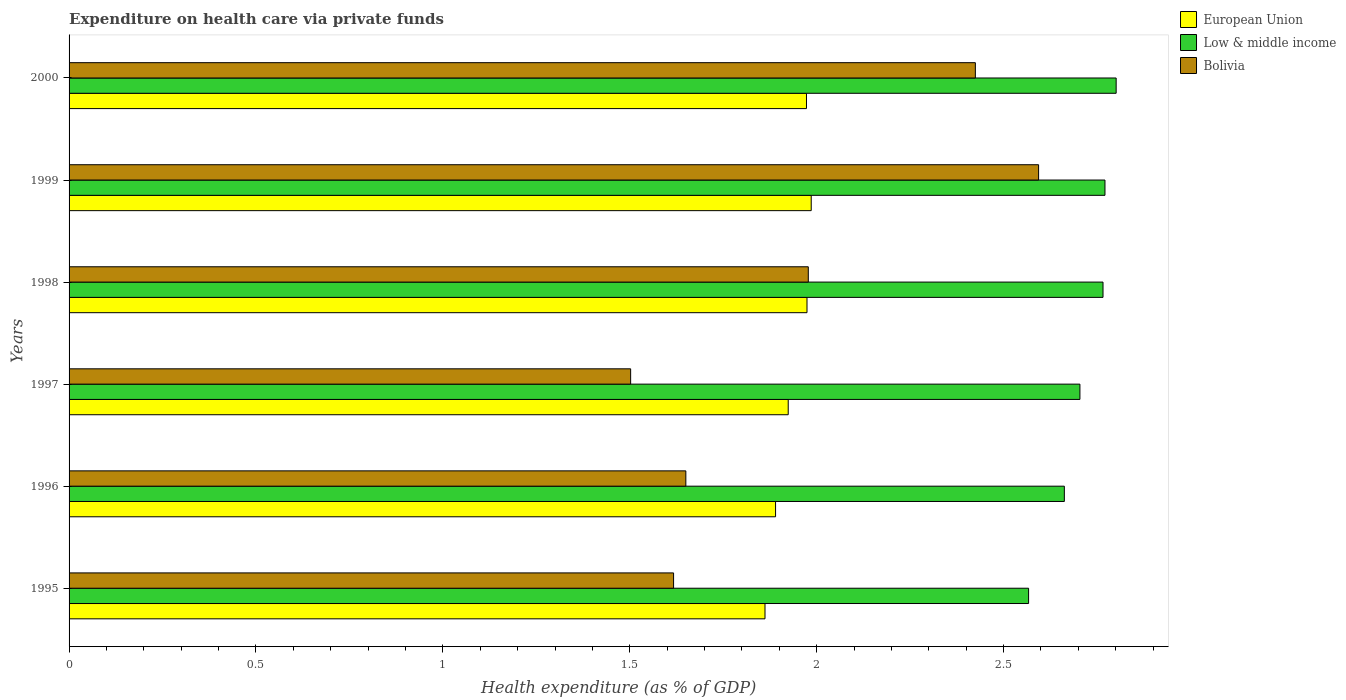How many different coloured bars are there?
Make the answer very short. 3. What is the expenditure made on health care in Low & middle income in 1995?
Your response must be concise. 2.57. Across all years, what is the maximum expenditure made on health care in Low & middle income?
Ensure brevity in your answer.  2.8. Across all years, what is the minimum expenditure made on health care in Low & middle income?
Ensure brevity in your answer.  2.57. In which year was the expenditure made on health care in Low & middle income maximum?
Keep it short and to the point. 2000. What is the total expenditure made on health care in Low & middle income in the graph?
Offer a very short reply. 16.27. What is the difference between the expenditure made on health care in European Union in 1995 and that in 1997?
Your answer should be compact. -0.06. What is the difference between the expenditure made on health care in Low & middle income in 1997 and the expenditure made on health care in European Union in 1995?
Your response must be concise. 0.84. What is the average expenditure made on health care in European Union per year?
Your answer should be very brief. 1.93. In the year 1999, what is the difference between the expenditure made on health care in Low & middle income and expenditure made on health care in European Union?
Your answer should be compact. 0.79. In how many years, is the expenditure made on health care in Low & middle income greater than 1.1 %?
Your answer should be compact. 6. What is the ratio of the expenditure made on health care in European Union in 1999 to that in 2000?
Offer a very short reply. 1.01. Is the expenditure made on health care in Bolivia in 1995 less than that in 1999?
Ensure brevity in your answer.  Yes. Is the difference between the expenditure made on health care in Low & middle income in 1995 and 1999 greater than the difference between the expenditure made on health care in European Union in 1995 and 1999?
Your answer should be very brief. No. What is the difference between the highest and the second highest expenditure made on health care in Bolivia?
Make the answer very short. 0.17. What is the difference between the highest and the lowest expenditure made on health care in Low & middle income?
Provide a short and direct response. 0.23. What does the 3rd bar from the top in 1997 represents?
Ensure brevity in your answer.  European Union. How many years are there in the graph?
Your response must be concise. 6. Are the values on the major ticks of X-axis written in scientific E-notation?
Offer a very short reply. No. What is the title of the graph?
Ensure brevity in your answer.  Expenditure on health care via private funds. Does "Australia" appear as one of the legend labels in the graph?
Ensure brevity in your answer.  No. What is the label or title of the X-axis?
Give a very brief answer. Health expenditure (as % of GDP). What is the label or title of the Y-axis?
Keep it short and to the point. Years. What is the Health expenditure (as % of GDP) in European Union in 1995?
Make the answer very short. 1.86. What is the Health expenditure (as % of GDP) of Low & middle income in 1995?
Your response must be concise. 2.57. What is the Health expenditure (as % of GDP) in Bolivia in 1995?
Ensure brevity in your answer.  1.62. What is the Health expenditure (as % of GDP) in European Union in 1996?
Provide a short and direct response. 1.89. What is the Health expenditure (as % of GDP) of Low & middle income in 1996?
Provide a short and direct response. 2.66. What is the Health expenditure (as % of GDP) of Bolivia in 1996?
Offer a very short reply. 1.65. What is the Health expenditure (as % of GDP) of European Union in 1997?
Offer a terse response. 1.92. What is the Health expenditure (as % of GDP) in Low & middle income in 1997?
Your response must be concise. 2.7. What is the Health expenditure (as % of GDP) in Bolivia in 1997?
Keep it short and to the point. 1.5. What is the Health expenditure (as % of GDP) in European Union in 1998?
Provide a succinct answer. 1.97. What is the Health expenditure (as % of GDP) of Low & middle income in 1998?
Offer a very short reply. 2.77. What is the Health expenditure (as % of GDP) in Bolivia in 1998?
Provide a succinct answer. 1.98. What is the Health expenditure (as % of GDP) in European Union in 1999?
Keep it short and to the point. 1.99. What is the Health expenditure (as % of GDP) of Low & middle income in 1999?
Give a very brief answer. 2.77. What is the Health expenditure (as % of GDP) in Bolivia in 1999?
Your answer should be compact. 2.59. What is the Health expenditure (as % of GDP) in European Union in 2000?
Keep it short and to the point. 1.97. What is the Health expenditure (as % of GDP) in Low & middle income in 2000?
Give a very brief answer. 2.8. What is the Health expenditure (as % of GDP) of Bolivia in 2000?
Keep it short and to the point. 2.42. Across all years, what is the maximum Health expenditure (as % of GDP) of European Union?
Keep it short and to the point. 1.99. Across all years, what is the maximum Health expenditure (as % of GDP) in Low & middle income?
Make the answer very short. 2.8. Across all years, what is the maximum Health expenditure (as % of GDP) of Bolivia?
Give a very brief answer. 2.59. Across all years, what is the minimum Health expenditure (as % of GDP) of European Union?
Make the answer very short. 1.86. Across all years, what is the minimum Health expenditure (as % of GDP) in Low & middle income?
Give a very brief answer. 2.57. Across all years, what is the minimum Health expenditure (as % of GDP) of Bolivia?
Your response must be concise. 1.5. What is the total Health expenditure (as % of GDP) of European Union in the graph?
Provide a short and direct response. 11.61. What is the total Health expenditure (as % of GDP) of Low & middle income in the graph?
Keep it short and to the point. 16.27. What is the total Health expenditure (as % of GDP) of Bolivia in the graph?
Offer a very short reply. 11.77. What is the difference between the Health expenditure (as % of GDP) in European Union in 1995 and that in 1996?
Provide a short and direct response. -0.03. What is the difference between the Health expenditure (as % of GDP) in Low & middle income in 1995 and that in 1996?
Offer a very short reply. -0.1. What is the difference between the Health expenditure (as % of GDP) in Bolivia in 1995 and that in 1996?
Ensure brevity in your answer.  -0.03. What is the difference between the Health expenditure (as % of GDP) in European Union in 1995 and that in 1997?
Ensure brevity in your answer.  -0.06. What is the difference between the Health expenditure (as % of GDP) in Low & middle income in 1995 and that in 1997?
Your answer should be compact. -0.14. What is the difference between the Health expenditure (as % of GDP) in Bolivia in 1995 and that in 1997?
Offer a terse response. 0.11. What is the difference between the Health expenditure (as % of GDP) in European Union in 1995 and that in 1998?
Your answer should be very brief. -0.11. What is the difference between the Health expenditure (as % of GDP) in Low & middle income in 1995 and that in 1998?
Make the answer very short. -0.2. What is the difference between the Health expenditure (as % of GDP) of Bolivia in 1995 and that in 1998?
Your answer should be compact. -0.36. What is the difference between the Health expenditure (as % of GDP) of European Union in 1995 and that in 1999?
Your response must be concise. -0.12. What is the difference between the Health expenditure (as % of GDP) of Low & middle income in 1995 and that in 1999?
Keep it short and to the point. -0.2. What is the difference between the Health expenditure (as % of GDP) in Bolivia in 1995 and that in 1999?
Keep it short and to the point. -0.98. What is the difference between the Health expenditure (as % of GDP) of European Union in 1995 and that in 2000?
Provide a short and direct response. -0.11. What is the difference between the Health expenditure (as % of GDP) in Low & middle income in 1995 and that in 2000?
Give a very brief answer. -0.23. What is the difference between the Health expenditure (as % of GDP) in Bolivia in 1995 and that in 2000?
Your answer should be compact. -0.81. What is the difference between the Health expenditure (as % of GDP) in European Union in 1996 and that in 1997?
Provide a succinct answer. -0.03. What is the difference between the Health expenditure (as % of GDP) of Low & middle income in 1996 and that in 1997?
Provide a succinct answer. -0.04. What is the difference between the Health expenditure (as % of GDP) in Bolivia in 1996 and that in 1997?
Keep it short and to the point. 0.15. What is the difference between the Health expenditure (as % of GDP) of European Union in 1996 and that in 1998?
Provide a succinct answer. -0.08. What is the difference between the Health expenditure (as % of GDP) of Low & middle income in 1996 and that in 1998?
Keep it short and to the point. -0.1. What is the difference between the Health expenditure (as % of GDP) of Bolivia in 1996 and that in 1998?
Offer a terse response. -0.33. What is the difference between the Health expenditure (as % of GDP) of European Union in 1996 and that in 1999?
Your answer should be compact. -0.1. What is the difference between the Health expenditure (as % of GDP) in Low & middle income in 1996 and that in 1999?
Offer a very short reply. -0.11. What is the difference between the Health expenditure (as % of GDP) of Bolivia in 1996 and that in 1999?
Keep it short and to the point. -0.94. What is the difference between the Health expenditure (as % of GDP) in European Union in 1996 and that in 2000?
Make the answer very short. -0.08. What is the difference between the Health expenditure (as % of GDP) of Low & middle income in 1996 and that in 2000?
Your response must be concise. -0.14. What is the difference between the Health expenditure (as % of GDP) in Bolivia in 1996 and that in 2000?
Offer a terse response. -0.77. What is the difference between the Health expenditure (as % of GDP) of European Union in 1997 and that in 1998?
Offer a terse response. -0.05. What is the difference between the Health expenditure (as % of GDP) in Low & middle income in 1997 and that in 1998?
Provide a short and direct response. -0.06. What is the difference between the Health expenditure (as % of GDP) of Bolivia in 1997 and that in 1998?
Offer a terse response. -0.48. What is the difference between the Health expenditure (as % of GDP) of European Union in 1997 and that in 1999?
Your response must be concise. -0.06. What is the difference between the Health expenditure (as % of GDP) in Low & middle income in 1997 and that in 1999?
Provide a short and direct response. -0.07. What is the difference between the Health expenditure (as % of GDP) in Bolivia in 1997 and that in 1999?
Keep it short and to the point. -1.09. What is the difference between the Health expenditure (as % of GDP) of European Union in 1997 and that in 2000?
Ensure brevity in your answer.  -0.05. What is the difference between the Health expenditure (as % of GDP) in Low & middle income in 1997 and that in 2000?
Keep it short and to the point. -0.1. What is the difference between the Health expenditure (as % of GDP) of Bolivia in 1997 and that in 2000?
Your answer should be very brief. -0.92. What is the difference between the Health expenditure (as % of GDP) in European Union in 1998 and that in 1999?
Make the answer very short. -0.01. What is the difference between the Health expenditure (as % of GDP) of Low & middle income in 1998 and that in 1999?
Provide a short and direct response. -0.01. What is the difference between the Health expenditure (as % of GDP) of Bolivia in 1998 and that in 1999?
Provide a succinct answer. -0.62. What is the difference between the Health expenditure (as % of GDP) in European Union in 1998 and that in 2000?
Give a very brief answer. 0. What is the difference between the Health expenditure (as % of GDP) in Low & middle income in 1998 and that in 2000?
Ensure brevity in your answer.  -0.04. What is the difference between the Health expenditure (as % of GDP) in Bolivia in 1998 and that in 2000?
Keep it short and to the point. -0.45. What is the difference between the Health expenditure (as % of GDP) of European Union in 1999 and that in 2000?
Offer a terse response. 0.01. What is the difference between the Health expenditure (as % of GDP) of Low & middle income in 1999 and that in 2000?
Offer a terse response. -0.03. What is the difference between the Health expenditure (as % of GDP) of Bolivia in 1999 and that in 2000?
Your answer should be very brief. 0.17. What is the difference between the Health expenditure (as % of GDP) of European Union in 1995 and the Health expenditure (as % of GDP) of Low & middle income in 1996?
Your response must be concise. -0.8. What is the difference between the Health expenditure (as % of GDP) in European Union in 1995 and the Health expenditure (as % of GDP) in Bolivia in 1996?
Your answer should be very brief. 0.21. What is the difference between the Health expenditure (as % of GDP) of Low & middle income in 1995 and the Health expenditure (as % of GDP) of Bolivia in 1996?
Provide a succinct answer. 0.92. What is the difference between the Health expenditure (as % of GDP) in European Union in 1995 and the Health expenditure (as % of GDP) in Low & middle income in 1997?
Offer a terse response. -0.84. What is the difference between the Health expenditure (as % of GDP) of European Union in 1995 and the Health expenditure (as % of GDP) of Bolivia in 1997?
Offer a terse response. 0.36. What is the difference between the Health expenditure (as % of GDP) in Low & middle income in 1995 and the Health expenditure (as % of GDP) in Bolivia in 1997?
Your response must be concise. 1.06. What is the difference between the Health expenditure (as % of GDP) of European Union in 1995 and the Health expenditure (as % of GDP) of Low & middle income in 1998?
Offer a very short reply. -0.9. What is the difference between the Health expenditure (as % of GDP) of European Union in 1995 and the Health expenditure (as % of GDP) of Bolivia in 1998?
Your response must be concise. -0.12. What is the difference between the Health expenditure (as % of GDP) of Low & middle income in 1995 and the Health expenditure (as % of GDP) of Bolivia in 1998?
Offer a very short reply. 0.59. What is the difference between the Health expenditure (as % of GDP) in European Union in 1995 and the Health expenditure (as % of GDP) in Low & middle income in 1999?
Offer a terse response. -0.91. What is the difference between the Health expenditure (as % of GDP) of European Union in 1995 and the Health expenditure (as % of GDP) of Bolivia in 1999?
Make the answer very short. -0.73. What is the difference between the Health expenditure (as % of GDP) of Low & middle income in 1995 and the Health expenditure (as % of GDP) of Bolivia in 1999?
Your answer should be very brief. -0.03. What is the difference between the Health expenditure (as % of GDP) in European Union in 1995 and the Health expenditure (as % of GDP) in Low & middle income in 2000?
Provide a succinct answer. -0.94. What is the difference between the Health expenditure (as % of GDP) of European Union in 1995 and the Health expenditure (as % of GDP) of Bolivia in 2000?
Offer a very short reply. -0.56. What is the difference between the Health expenditure (as % of GDP) in Low & middle income in 1995 and the Health expenditure (as % of GDP) in Bolivia in 2000?
Give a very brief answer. 0.14. What is the difference between the Health expenditure (as % of GDP) of European Union in 1996 and the Health expenditure (as % of GDP) of Low & middle income in 1997?
Ensure brevity in your answer.  -0.81. What is the difference between the Health expenditure (as % of GDP) in European Union in 1996 and the Health expenditure (as % of GDP) in Bolivia in 1997?
Your response must be concise. 0.39. What is the difference between the Health expenditure (as % of GDP) in Low & middle income in 1996 and the Health expenditure (as % of GDP) in Bolivia in 1997?
Provide a short and direct response. 1.16. What is the difference between the Health expenditure (as % of GDP) of European Union in 1996 and the Health expenditure (as % of GDP) of Low & middle income in 1998?
Make the answer very short. -0.88. What is the difference between the Health expenditure (as % of GDP) in European Union in 1996 and the Health expenditure (as % of GDP) in Bolivia in 1998?
Give a very brief answer. -0.09. What is the difference between the Health expenditure (as % of GDP) in Low & middle income in 1996 and the Health expenditure (as % of GDP) in Bolivia in 1998?
Your response must be concise. 0.69. What is the difference between the Health expenditure (as % of GDP) in European Union in 1996 and the Health expenditure (as % of GDP) in Low & middle income in 1999?
Your answer should be compact. -0.88. What is the difference between the Health expenditure (as % of GDP) of European Union in 1996 and the Health expenditure (as % of GDP) of Bolivia in 1999?
Your answer should be very brief. -0.7. What is the difference between the Health expenditure (as % of GDP) of Low & middle income in 1996 and the Health expenditure (as % of GDP) of Bolivia in 1999?
Make the answer very short. 0.07. What is the difference between the Health expenditure (as % of GDP) of European Union in 1996 and the Health expenditure (as % of GDP) of Low & middle income in 2000?
Your answer should be compact. -0.91. What is the difference between the Health expenditure (as % of GDP) of European Union in 1996 and the Health expenditure (as % of GDP) of Bolivia in 2000?
Give a very brief answer. -0.53. What is the difference between the Health expenditure (as % of GDP) in Low & middle income in 1996 and the Health expenditure (as % of GDP) in Bolivia in 2000?
Your answer should be very brief. 0.24. What is the difference between the Health expenditure (as % of GDP) of European Union in 1997 and the Health expenditure (as % of GDP) of Low & middle income in 1998?
Provide a short and direct response. -0.84. What is the difference between the Health expenditure (as % of GDP) in European Union in 1997 and the Health expenditure (as % of GDP) in Bolivia in 1998?
Offer a terse response. -0.05. What is the difference between the Health expenditure (as % of GDP) in Low & middle income in 1997 and the Health expenditure (as % of GDP) in Bolivia in 1998?
Your answer should be compact. 0.73. What is the difference between the Health expenditure (as % of GDP) in European Union in 1997 and the Health expenditure (as % of GDP) in Low & middle income in 1999?
Provide a short and direct response. -0.85. What is the difference between the Health expenditure (as % of GDP) of European Union in 1997 and the Health expenditure (as % of GDP) of Bolivia in 1999?
Your answer should be compact. -0.67. What is the difference between the Health expenditure (as % of GDP) of Low & middle income in 1997 and the Health expenditure (as % of GDP) of Bolivia in 1999?
Your answer should be very brief. 0.11. What is the difference between the Health expenditure (as % of GDP) of European Union in 1997 and the Health expenditure (as % of GDP) of Low & middle income in 2000?
Offer a terse response. -0.88. What is the difference between the Health expenditure (as % of GDP) of European Union in 1997 and the Health expenditure (as % of GDP) of Bolivia in 2000?
Offer a very short reply. -0.5. What is the difference between the Health expenditure (as % of GDP) of Low & middle income in 1997 and the Health expenditure (as % of GDP) of Bolivia in 2000?
Your response must be concise. 0.28. What is the difference between the Health expenditure (as % of GDP) of European Union in 1998 and the Health expenditure (as % of GDP) of Low & middle income in 1999?
Your answer should be compact. -0.8. What is the difference between the Health expenditure (as % of GDP) of European Union in 1998 and the Health expenditure (as % of GDP) of Bolivia in 1999?
Offer a terse response. -0.62. What is the difference between the Health expenditure (as % of GDP) in Low & middle income in 1998 and the Health expenditure (as % of GDP) in Bolivia in 1999?
Keep it short and to the point. 0.17. What is the difference between the Health expenditure (as % of GDP) in European Union in 1998 and the Health expenditure (as % of GDP) in Low & middle income in 2000?
Offer a terse response. -0.83. What is the difference between the Health expenditure (as % of GDP) of European Union in 1998 and the Health expenditure (as % of GDP) of Bolivia in 2000?
Your response must be concise. -0.45. What is the difference between the Health expenditure (as % of GDP) in Low & middle income in 1998 and the Health expenditure (as % of GDP) in Bolivia in 2000?
Provide a short and direct response. 0.34. What is the difference between the Health expenditure (as % of GDP) of European Union in 1999 and the Health expenditure (as % of GDP) of Low & middle income in 2000?
Make the answer very short. -0.82. What is the difference between the Health expenditure (as % of GDP) of European Union in 1999 and the Health expenditure (as % of GDP) of Bolivia in 2000?
Your response must be concise. -0.44. What is the difference between the Health expenditure (as % of GDP) in Low & middle income in 1999 and the Health expenditure (as % of GDP) in Bolivia in 2000?
Make the answer very short. 0.35. What is the average Health expenditure (as % of GDP) of European Union per year?
Provide a short and direct response. 1.93. What is the average Health expenditure (as % of GDP) of Low & middle income per year?
Keep it short and to the point. 2.71. What is the average Health expenditure (as % of GDP) in Bolivia per year?
Your answer should be compact. 1.96. In the year 1995, what is the difference between the Health expenditure (as % of GDP) in European Union and Health expenditure (as % of GDP) in Low & middle income?
Keep it short and to the point. -0.71. In the year 1995, what is the difference between the Health expenditure (as % of GDP) in European Union and Health expenditure (as % of GDP) in Bolivia?
Your answer should be compact. 0.24. In the year 1995, what is the difference between the Health expenditure (as % of GDP) of Low & middle income and Health expenditure (as % of GDP) of Bolivia?
Your response must be concise. 0.95. In the year 1996, what is the difference between the Health expenditure (as % of GDP) in European Union and Health expenditure (as % of GDP) in Low & middle income?
Your answer should be compact. -0.77. In the year 1996, what is the difference between the Health expenditure (as % of GDP) in European Union and Health expenditure (as % of GDP) in Bolivia?
Your response must be concise. 0.24. In the year 1996, what is the difference between the Health expenditure (as % of GDP) of Low & middle income and Health expenditure (as % of GDP) of Bolivia?
Provide a short and direct response. 1.01. In the year 1997, what is the difference between the Health expenditure (as % of GDP) in European Union and Health expenditure (as % of GDP) in Low & middle income?
Your answer should be compact. -0.78. In the year 1997, what is the difference between the Health expenditure (as % of GDP) of European Union and Health expenditure (as % of GDP) of Bolivia?
Provide a succinct answer. 0.42. In the year 1997, what is the difference between the Health expenditure (as % of GDP) in Low & middle income and Health expenditure (as % of GDP) in Bolivia?
Keep it short and to the point. 1.2. In the year 1998, what is the difference between the Health expenditure (as % of GDP) of European Union and Health expenditure (as % of GDP) of Low & middle income?
Give a very brief answer. -0.79. In the year 1998, what is the difference between the Health expenditure (as % of GDP) of European Union and Health expenditure (as % of GDP) of Bolivia?
Your answer should be compact. -0. In the year 1998, what is the difference between the Health expenditure (as % of GDP) in Low & middle income and Health expenditure (as % of GDP) in Bolivia?
Offer a terse response. 0.79. In the year 1999, what is the difference between the Health expenditure (as % of GDP) in European Union and Health expenditure (as % of GDP) in Low & middle income?
Ensure brevity in your answer.  -0.79. In the year 1999, what is the difference between the Health expenditure (as % of GDP) in European Union and Health expenditure (as % of GDP) in Bolivia?
Offer a terse response. -0.61. In the year 1999, what is the difference between the Health expenditure (as % of GDP) of Low & middle income and Health expenditure (as % of GDP) of Bolivia?
Make the answer very short. 0.18. In the year 2000, what is the difference between the Health expenditure (as % of GDP) of European Union and Health expenditure (as % of GDP) of Low & middle income?
Ensure brevity in your answer.  -0.83. In the year 2000, what is the difference between the Health expenditure (as % of GDP) in European Union and Health expenditure (as % of GDP) in Bolivia?
Offer a very short reply. -0.45. In the year 2000, what is the difference between the Health expenditure (as % of GDP) in Low & middle income and Health expenditure (as % of GDP) in Bolivia?
Make the answer very short. 0.38. What is the ratio of the Health expenditure (as % of GDP) in European Union in 1995 to that in 1996?
Your response must be concise. 0.99. What is the ratio of the Health expenditure (as % of GDP) of Low & middle income in 1995 to that in 1996?
Keep it short and to the point. 0.96. What is the ratio of the Health expenditure (as % of GDP) in Bolivia in 1995 to that in 1996?
Your answer should be very brief. 0.98. What is the ratio of the Health expenditure (as % of GDP) in European Union in 1995 to that in 1997?
Your answer should be very brief. 0.97. What is the ratio of the Health expenditure (as % of GDP) in Low & middle income in 1995 to that in 1997?
Your answer should be very brief. 0.95. What is the ratio of the Health expenditure (as % of GDP) in Bolivia in 1995 to that in 1997?
Make the answer very short. 1.08. What is the ratio of the Health expenditure (as % of GDP) in European Union in 1995 to that in 1998?
Provide a short and direct response. 0.94. What is the ratio of the Health expenditure (as % of GDP) of Low & middle income in 1995 to that in 1998?
Keep it short and to the point. 0.93. What is the ratio of the Health expenditure (as % of GDP) in Bolivia in 1995 to that in 1998?
Your answer should be compact. 0.82. What is the ratio of the Health expenditure (as % of GDP) of European Union in 1995 to that in 1999?
Your response must be concise. 0.94. What is the ratio of the Health expenditure (as % of GDP) of Low & middle income in 1995 to that in 1999?
Make the answer very short. 0.93. What is the ratio of the Health expenditure (as % of GDP) of Bolivia in 1995 to that in 1999?
Give a very brief answer. 0.62. What is the ratio of the Health expenditure (as % of GDP) in European Union in 1995 to that in 2000?
Provide a short and direct response. 0.94. What is the ratio of the Health expenditure (as % of GDP) of Low & middle income in 1995 to that in 2000?
Give a very brief answer. 0.92. What is the ratio of the Health expenditure (as % of GDP) of Bolivia in 1995 to that in 2000?
Provide a short and direct response. 0.67. What is the ratio of the Health expenditure (as % of GDP) in European Union in 1996 to that in 1997?
Offer a terse response. 0.98. What is the ratio of the Health expenditure (as % of GDP) in Low & middle income in 1996 to that in 1997?
Ensure brevity in your answer.  0.98. What is the ratio of the Health expenditure (as % of GDP) of Bolivia in 1996 to that in 1997?
Offer a very short reply. 1.1. What is the ratio of the Health expenditure (as % of GDP) in European Union in 1996 to that in 1998?
Make the answer very short. 0.96. What is the ratio of the Health expenditure (as % of GDP) in Low & middle income in 1996 to that in 1998?
Your response must be concise. 0.96. What is the ratio of the Health expenditure (as % of GDP) of Bolivia in 1996 to that in 1998?
Your answer should be compact. 0.83. What is the ratio of the Health expenditure (as % of GDP) of Low & middle income in 1996 to that in 1999?
Offer a terse response. 0.96. What is the ratio of the Health expenditure (as % of GDP) in Bolivia in 1996 to that in 1999?
Keep it short and to the point. 0.64. What is the ratio of the Health expenditure (as % of GDP) of European Union in 1996 to that in 2000?
Ensure brevity in your answer.  0.96. What is the ratio of the Health expenditure (as % of GDP) of Low & middle income in 1996 to that in 2000?
Make the answer very short. 0.95. What is the ratio of the Health expenditure (as % of GDP) in Bolivia in 1996 to that in 2000?
Offer a very short reply. 0.68. What is the ratio of the Health expenditure (as % of GDP) of European Union in 1997 to that in 1998?
Ensure brevity in your answer.  0.97. What is the ratio of the Health expenditure (as % of GDP) of Low & middle income in 1997 to that in 1998?
Your answer should be compact. 0.98. What is the ratio of the Health expenditure (as % of GDP) of Bolivia in 1997 to that in 1998?
Provide a short and direct response. 0.76. What is the ratio of the Health expenditure (as % of GDP) of European Union in 1997 to that in 1999?
Your response must be concise. 0.97. What is the ratio of the Health expenditure (as % of GDP) in Low & middle income in 1997 to that in 1999?
Keep it short and to the point. 0.98. What is the ratio of the Health expenditure (as % of GDP) of Bolivia in 1997 to that in 1999?
Offer a terse response. 0.58. What is the ratio of the Health expenditure (as % of GDP) of European Union in 1997 to that in 2000?
Keep it short and to the point. 0.98. What is the ratio of the Health expenditure (as % of GDP) in Low & middle income in 1997 to that in 2000?
Your answer should be very brief. 0.97. What is the ratio of the Health expenditure (as % of GDP) in Bolivia in 1997 to that in 2000?
Provide a short and direct response. 0.62. What is the ratio of the Health expenditure (as % of GDP) of European Union in 1998 to that in 1999?
Ensure brevity in your answer.  0.99. What is the ratio of the Health expenditure (as % of GDP) of Low & middle income in 1998 to that in 1999?
Make the answer very short. 1. What is the ratio of the Health expenditure (as % of GDP) in Bolivia in 1998 to that in 1999?
Provide a short and direct response. 0.76. What is the ratio of the Health expenditure (as % of GDP) in Low & middle income in 1998 to that in 2000?
Your answer should be compact. 0.99. What is the ratio of the Health expenditure (as % of GDP) of Bolivia in 1998 to that in 2000?
Ensure brevity in your answer.  0.82. What is the ratio of the Health expenditure (as % of GDP) in European Union in 1999 to that in 2000?
Give a very brief answer. 1.01. What is the ratio of the Health expenditure (as % of GDP) of Low & middle income in 1999 to that in 2000?
Provide a short and direct response. 0.99. What is the ratio of the Health expenditure (as % of GDP) in Bolivia in 1999 to that in 2000?
Your answer should be very brief. 1.07. What is the difference between the highest and the second highest Health expenditure (as % of GDP) of European Union?
Provide a short and direct response. 0.01. What is the difference between the highest and the second highest Health expenditure (as % of GDP) of Low & middle income?
Your answer should be very brief. 0.03. What is the difference between the highest and the second highest Health expenditure (as % of GDP) of Bolivia?
Your response must be concise. 0.17. What is the difference between the highest and the lowest Health expenditure (as % of GDP) in European Union?
Ensure brevity in your answer.  0.12. What is the difference between the highest and the lowest Health expenditure (as % of GDP) of Low & middle income?
Offer a terse response. 0.23. What is the difference between the highest and the lowest Health expenditure (as % of GDP) of Bolivia?
Your answer should be compact. 1.09. 